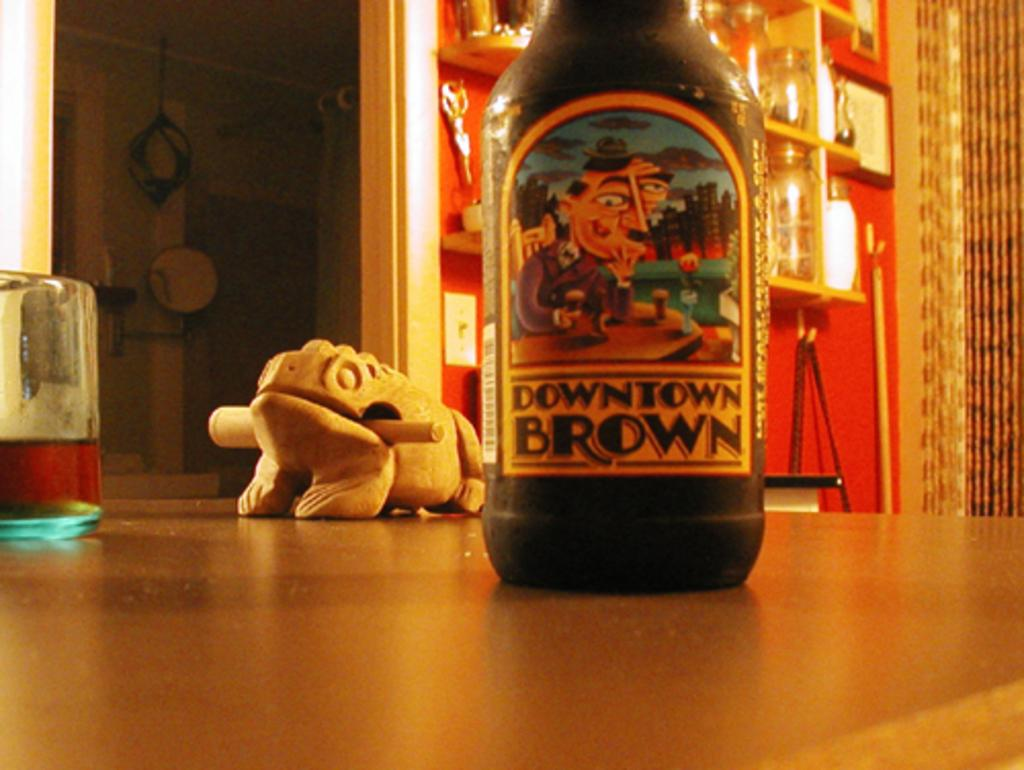<image>
Render a clear and concise summary of the photo. A bottle of "Downtown Brown" beer sitting on a table top. 